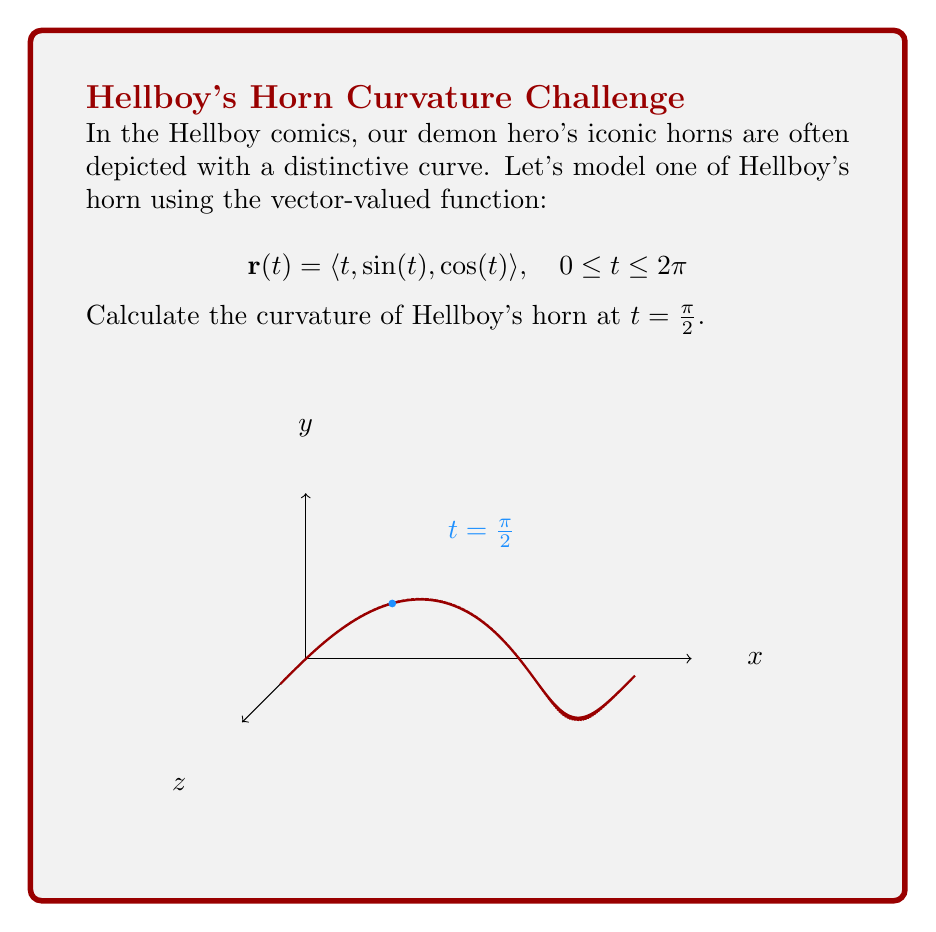Give your solution to this math problem. To find the curvature of Hellboy's horn, we'll use the formula:

$$\kappa = \frac{|\mathbf{r}'(t) \times \mathbf{r}''(t)|}{|\mathbf{r}'(t)|^3}$$

Step 1: Calculate $\mathbf{r}'(t)$
$$\mathbf{r}'(t) = \langle 1, \cos(t), -\sin(t) \rangle$$

Step 2: Calculate $\mathbf{r}''(t)$
$$\mathbf{r}''(t) = \langle 0, -\sin(t), -\cos(t) \rangle$$

Step 3: Calculate $\mathbf{r}'(t) \times \mathbf{r}''(t)$
$$\begin{aligned}
\mathbf{r}'(t) \times \mathbf{r}''(t) &= \begin{vmatrix}
\mathbf{i} & \mathbf{j} & \mathbf{k} \\
1 & \cos(t) & -\sin(t) \\
0 & -\sin(t) & -\cos(t)
\end{vmatrix} \\
&= \langle -\cos^2(t) - \sin^2(t), \sin(t), -\cos(t) \rangle \\
&= \langle -1, \sin(t), -\cos(t) \rangle
\end{aligned}$$

Step 4: Calculate $|\mathbf{r}'(t) \times \mathbf{r}''(t)|$
$$|\mathbf{r}'(t) \times \mathbf{r}''(t)| = \sqrt{(-1)^2 + \sin^2(t) + \cos^2(t)} = \sqrt{2}$$

Step 5: Calculate $|\mathbf{r}'(t)|$
$$|\mathbf{r}'(t)| = \sqrt{1^2 + \cos^2(t) + \sin^2(t)} = \sqrt{2}$$

Step 6: Apply the curvature formula at $t = \frac{\pi}{2}$
$$\kappa = \frac{|\mathbf{r}'(\frac{\pi}{2}) \times \mathbf{r}''(\frac{\pi}{2})|}{|\mathbf{r}'(\frac{\pi}{2})|^3} = \frac{\sqrt{2}}{(\sqrt{2})^3} = \frac{\sqrt{2}}{2\sqrt{2}} = \frac{1}{2}$$
Answer: $\frac{1}{2}$ 